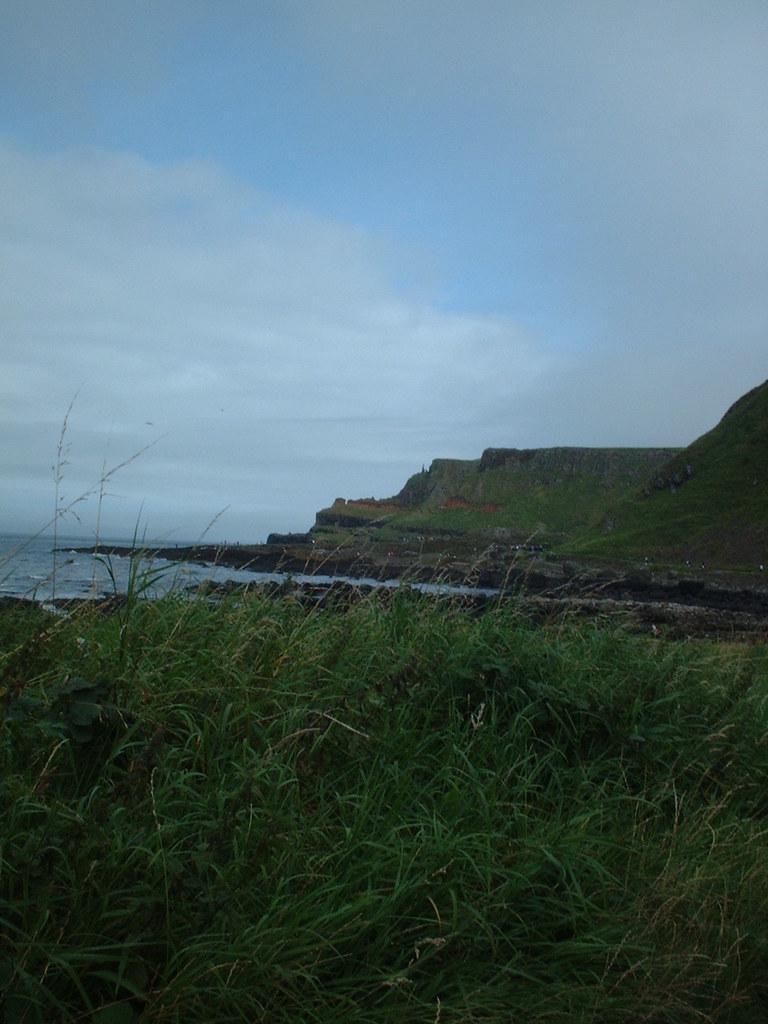How would you summarize this image in a sentence or two? In this I can see at the bottom there are plants, on the left side it looks like sea. At the top it is the cloudy sky. 